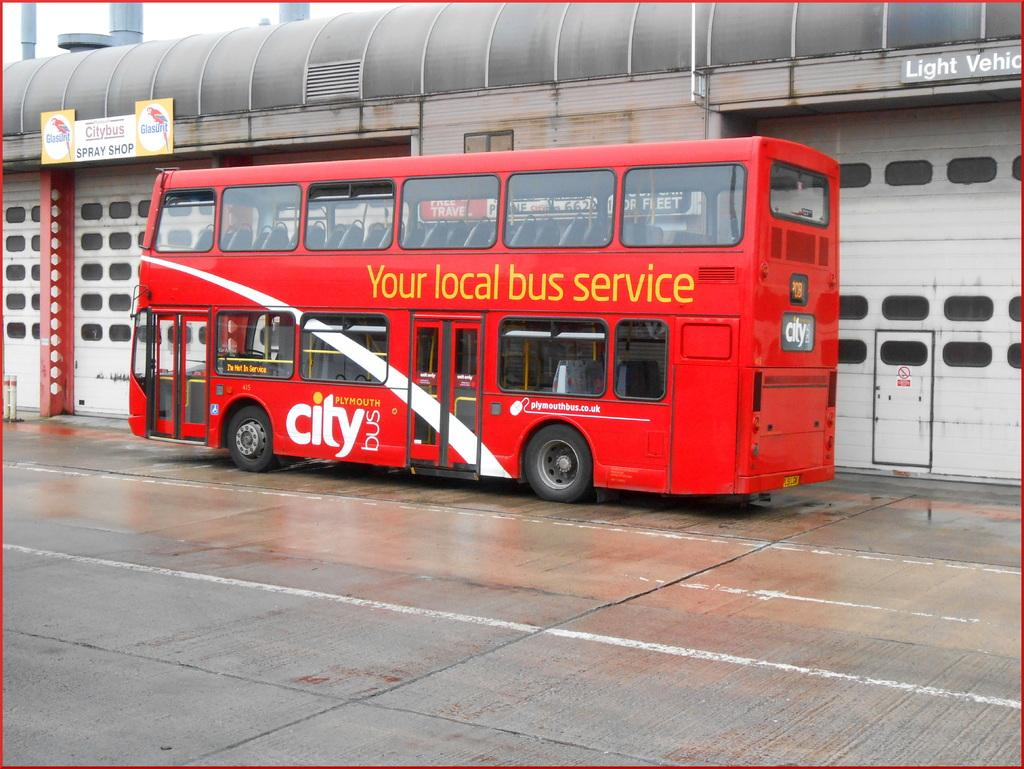What is the main subject of the image? There is a vehicle on the road in the image. What can be seen in the background of the image? There is a building in the background of the image. What is on the building? There are boards with text and images on the building. What type of class is being taught in the image? There is no class present in the image; it features a vehicle on the road and a building with boards. 